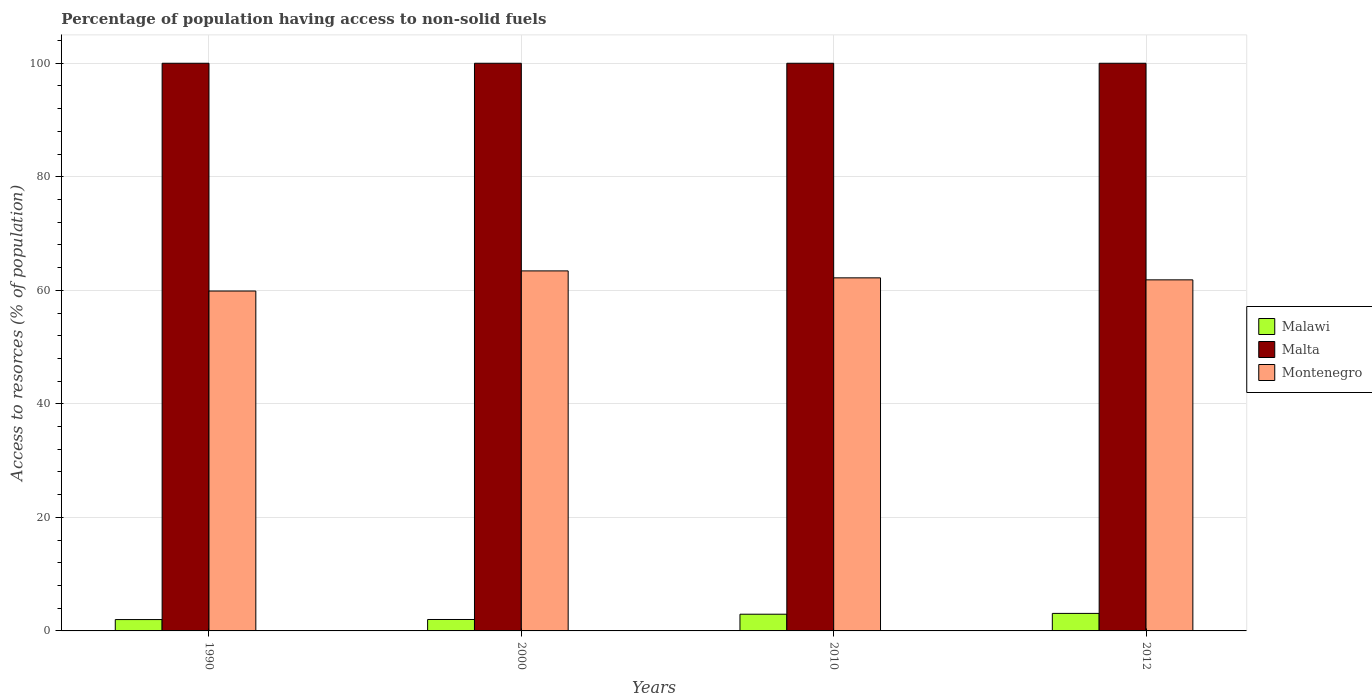Are the number of bars per tick equal to the number of legend labels?
Keep it short and to the point. Yes. Are the number of bars on each tick of the X-axis equal?
Provide a short and direct response. Yes. How many bars are there on the 2nd tick from the right?
Your response must be concise. 3. What is the percentage of population having access to non-solid fuels in Malawi in 2010?
Your answer should be compact. 2.94. Across all years, what is the maximum percentage of population having access to non-solid fuels in Montenegro?
Make the answer very short. 63.42. Across all years, what is the minimum percentage of population having access to non-solid fuels in Malawi?
Provide a short and direct response. 2. In which year was the percentage of population having access to non-solid fuels in Malta maximum?
Provide a succinct answer. 1990. In which year was the percentage of population having access to non-solid fuels in Malta minimum?
Your answer should be very brief. 1990. What is the total percentage of population having access to non-solid fuels in Malta in the graph?
Your answer should be very brief. 400. What is the difference between the percentage of population having access to non-solid fuels in Montenegro in 2000 and the percentage of population having access to non-solid fuels in Malta in 1990?
Offer a very short reply. -36.58. In the year 2012, what is the difference between the percentage of population having access to non-solid fuels in Montenegro and percentage of population having access to non-solid fuels in Malawi?
Give a very brief answer. 58.76. What is the ratio of the percentage of population having access to non-solid fuels in Malta in 1990 to that in 2000?
Make the answer very short. 1. What is the difference between the highest and the second highest percentage of population having access to non-solid fuels in Malawi?
Make the answer very short. 0.14. What is the difference between the highest and the lowest percentage of population having access to non-solid fuels in Montenegro?
Give a very brief answer. 3.54. Is the sum of the percentage of population having access to non-solid fuels in Malawi in 2010 and 2012 greater than the maximum percentage of population having access to non-solid fuels in Malta across all years?
Your answer should be very brief. No. What does the 1st bar from the left in 2000 represents?
Keep it short and to the point. Malawi. What does the 2nd bar from the right in 2012 represents?
Ensure brevity in your answer.  Malta. How many years are there in the graph?
Offer a terse response. 4. Are the values on the major ticks of Y-axis written in scientific E-notation?
Ensure brevity in your answer.  No. Does the graph contain any zero values?
Offer a very short reply. No. Where does the legend appear in the graph?
Give a very brief answer. Center right. What is the title of the graph?
Your answer should be compact. Percentage of population having access to non-solid fuels. What is the label or title of the Y-axis?
Your answer should be compact. Access to resorces (% of population). What is the Access to resorces (% of population) of Malawi in 1990?
Your answer should be compact. 2. What is the Access to resorces (% of population) in Malta in 1990?
Your answer should be very brief. 100. What is the Access to resorces (% of population) in Montenegro in 1990?
Give a very brief answer. 59.88. What is the Access to resorces (% of population) in Malawi in 2000?
Give a very brief answer. 2.01. What is the Access to resorces (% of population) in Malta in 2000?
Keep it short and to the point. 100. What is the Access to resorces (% of population) in Montenegro in 2000?
Your answer should be compact. 63.42. What is the Access to resorces (% of population) of Malawi in 2010?
Keep it short and to the point. 2.94. What is the Access to resorces (% of population) in Montenegro in 2010?
Provide a short and direct response. 62.2. What is the Access to resorces (% of population) of Malawi in 2012?
Make the answer very short. 3.09. What is the Access to resorces (% of population) of Malta in 2012?
Ensure brevity in your answer.  100. What is the Access to resorces (% of population) in Montenegro in 2012?
Offer a very short reply. 61.85. Across all years, what is the maximum Access to resorces (% of population) in Malawi?
Provide a succinct answer. 3.09. Across all years, what is the maximum Access to resorces (% of population) in Malta?
Your response must be concise. 100. Across all years, what is the maximum Access to resorces (% of population) in Montenegro?
Provide a short and direct response. 63.42. Across all years, what is the minimum Access to resorces (% of population) of Malawi?
Offer a terse response. 2. Across all years, what is the minimum Access to resorces (% of population) of Montenegro?
Make the answer very short. 59.88. What is the total Access to resorces (% of population) in Malawi in the graph?
Provide a short and direct response. 10.04. What is the total Access to resorces (% of population) of Malta in the graph?
Ensure brevity in your answer.  400. What is the total Access to resorces (% of population) of Montenegro in the graph?
Your response must be concise. 247.34. What is the difference between the Access to resorces (% of population) of Malawi in 1990 and that in 2000?
Your answer should be compact. -0.01. What is the difference between the Access to resorces (% of population) in Malta in 1990 and that in 2000?
Make the answer very short. 0. What is the difference between the Access to resorces (% of population) in Montenegro in 1990 and that in 2000?
Your response must be concise. -3.54. What is the difference between the Access to resorces (% of population) in Malawi in 1990 and that in 2010?
Offer a terse response. -0.94. What is the difference between the Access to resorces (% of population) of Montenegro in 1990 and that in 2010?
Your answer should be very brief. -2.32. What is the difference between the Access to resorces (% of population) of Malawi in 1990 and that in 2012?
Your response must be concise. -1.09. What is the difference between the Access to resorces (% of population) of Montenegro in 1990 and that in 2012?
Your response must be concise. -1.97. What is the difference between the Access to resorces (% of population) in Malawi in 2000 and that in 2010?
Offer a very short reply. -0.93. What is the difference between the Access to resorces (% of population) in Malta in 2000 and that in 2010?
Offer a terse response. 0. What is the difference between the Access to resorces (% of population) of Montenegro in 2000 and that in 2010?
Your response must be concise. 1.22. What is the difference between the Access to resorces (% of population) of Malawi in 2000 and that in 2012?
Your response must be concise. -1.07. What is the difference between the Access to resorces (% of population) of Montenegro in 2000 and that in 2012?
Provide a short and direct response. 1.58. What is the difference between the Access to resorces (% of population) of Malawi in 2010 and that in 2012?
Ensure brevity in your answer.  -0.14. What is the difference between the Access to resorces (% of population) in Montenegro in 2010 and that in 2012?
Give a very brief answer. 0.35. What is the difference between the Access to resorces (% of population) of Malawi in 1990 and the Access to resorces (% of population) of Malta in 2000?
Give a very brief answer. -98. What is the difference between the Access to resorces (% of population) of Malawi in 1990 and the Access to resorces (% of population) of Montenegro in 2000?
Keep it short and to the point. -61.42. What is the difference between the Access to resorces (% of population) of Malta in 1990 and the Access to resorces (% of population) of Montenegro in 2000?
Offer a terse response. 36.58. What is the difference between the Access to resorces (% of population) in Malawi in 1990 and the Access to resorces (% of population) in Malta in 2010?
Offer a terse response. -98. What is the difference between the Access to resorces (% of population) in Malawi in 1990 and the Access to resorces (% of population) in Montenegro in 2010?
Give a very brief answer. -60.2. What is the difference between the Access to resorces (% of population) in Malta in 1990 and the Access to resorces (% of population) in Montenegro in 2010?
Make the answer very short. 37.8. What is the difference between the Access to resorces (% of population) of Malawi in 1990 and the Access to resorces (% of population) of Malta in 2012?
Offer a terse response. -98. What is the difference between the Access to resorces (% of population) in Malawi in 1990 and the Access to resorces (% of population) in Montenegro in 2012?
Your answer should be compact. -59.85. What is the difference between the Access to resorces (% of population) of Malta in 1990 and the Access to resorces (% of population) of Montenegro in 2012?
Ensure brevity in your answer.  38.15. What is the difference between the Access to resorces (% of population) of Malawi in 2000 and the Access to resorces (% of population) of Malta in 2010?
Keep it short and to the point. -97.99. What is the difference between the Access to resorces (% of population) in Malawi in 2000 and the Access to resorces (% of population) in Montenegro in 2010?
Make the answer very short. -60.18. What is the difference between the Access to resorces (% of population) of Malta in 2000 and the Access to resorces (% of population) of Montenegro in 2010?
Your answer should be compact. 37.8. What is the difference between the Access to resorces (% of population) of Malawi in 2000 and the Access to resorces (% of population) of Malta in 2012?
Provide a succinct answer. -97.99. What is the difference between the Access to resorces (% of population) of Malawi in 2000 and the Access to resorces (% of population) of Montenegro in 2012?
Keep it short and to the point. -59.83. What is the difference between the Access to resorces (% of population) of Malta in 2000 and the Access to resorces (% of population) of Montenegro in 2012?
Ensure brevity in your answer.  38.15. What is the difference between the Access to resorces (% of population) in Malawi in 2010 and the Access to resorces (% of population) in Malta in 2012?
Provide a succinct answer. -97.06. What is the difference between the Access to resorces (% of population) of Malawi in 2010 and the Access to resorces (% of population) of Montenegro in 2012?
Give a very brief answer. -58.9. What is the difference between the Access to resorces (% of population) in Malta in 2010 and the Access to resorces (% of population) in Montenegro in 2012?
Offer a terse response. 38.15. What is the average Access to resorces (% of population) of Malawi per year?
Provide a short and direct response. 2.51. What is the average Access to resorces (% of population) of Malta per year?
Offer a terse response. 100. What is the average Access to resorces (% of population) in Montenegro per year?
Make the answer very short. 61.84. In the year 1990, what is the difference between the Access to resorces (% of population) of Malawi and Access to resorces (% of population) of Malta?
Give a very brief answer. -98. In the year 1990, what is the difference between the Access to resorces (% of population) in Malawi and Access to resorces (% of population) in Montenegro?
Offer a terse response. -57.88. In the year 1990, what is the difference between the Access to resorces (% of population) in Malta and Access to resorces (% of population) in Montenegro?
Your response must be concise. 40.12. In the year 2000, what is the difference between the Access to resorces (% of population) of Malawi and Access to resorces (% of population) of Malta?
Give a very brief answer. -97.99. In the year 2000, what is the difference between the Access to resorces (% of population) in Malawi and Access to resorces (% of population) in Montenegro?
Offer a very short reply. -61.41. In the year 2000, what is the difference between the Access to resorces (% of population) in Malta and Access to resorces (% of population) in Montenegro?
Your answer should be very brief. 36.58. In the year 2010, what is the difference between the Access to resorces (% of population) of Malawi and Access to resorces (% of population) of Malta?
Provide a short and direct response. -97.06. In the year 2010, what is the difference between the Access to resorces (% of population) in Malawi and Access to resorces (% of population) in Montenegro?
Provide a succinct answer. -59.25. In the year 2010, what is the difference between the Access to resorces (% of population) of Malta and Access to resorces (% of population) of Montenegro?
Keep it short and to the point. 37.8. In the year 2012, what is the difference between the Access to resorces (% of population) in Malawi and Access to resorces (% of population) in Malta?
Give a very brief answer. -96.91. In the year 2012, what is the difference between the Access to resorces (% of population) of Malawi and Access to resorces (% of population) of Montenegro?
Provide a succinct answer. -58.76. In the year 2012, what is the difference between the Access to resorces (% of population) of Malta and Access to resorces (% of population) of Montenegro?
Provide a succinct answer. 38.15. What is the ratio of the Access to resorces (% of population) in Malta in 1990 to that in 2000?
Give a very brief answer. 1. What is the ratio of the Access to resorces (% of population) of Montenegro in 1990 to that in 2000?
Your response must be concise. 0.94. What is the ratio of the Access to resorces (% of population) in Malawi in 1990 to that in 2010?
Keep it short and to the point. 0.68. What is the ratio of the Access to resorces (% of population) in Montenegro in 1990 to that in 2010?
Make the answer very short. 0.96. What is the ratio of the Access to resorces (% of population) in Malawi in 1990 to that in 2012?
Offer a terse response. 0.65. What is the ratio of the Access to resorces (% of population) of Montenegro in 1990 to that in 2012?
Ensure brevity in your answer.  0.97. What is the ratio of the Access to resorces (% of population) in Malawi in 2000 to that in 2010?
Give a very brief answer. 0.68. What is the ratio of the Access to resorces (% of population) of Malta in 2000 to that in 2010?
Provide a short and direct response. 1. What is the ratio of the Access to resorces (% of population) in Montenegro in 2000 to that in 2010?
Offer a very short reply. 1.02. What is the ratio of the Access to resorces (% of population) in Malawi in 2000 to that in 2012?
Keep it short and to the point. 0.65. What is the ratio of the Access to resorces (% of population) of Montenegro in 2000 to that in 2012?
Your answer should be compact. 1.03. What is the ratio of the Access to resorces (% of population) in Malawi in 2010 to that in 2012?
Your answer should be very brief. 0.95. What is the ratio of the Access to resorces (% of population) in Malta in 2010 to that in 2012?
Give a very brief answer. 1. What is the ratio of the Access to resorces (% of population) in Montenegro in 2010 to that in 2012?
Give a very brief answer. 1.01. What is the difference between the highest and the second highest Access to resorces (% of population) of Malawi?
Provide a short and direct response. 0.14. What is the difference between the highest and the second highest Access to resorces (% of population) in Malta?
Provide a succinct answer. 0. What is the difference between the highest and the second highest Access to resorces (% of population) in Montenegro?
Your answer should be compact. 1.22. What is the difference between the highest and the lowest Access to resorces (% of population) in Malawi?
Make the answer very short. 1.09. What is the difference between the highest and the lowest Access to resorces (% of population) in Malta?
Provide a succinct answer. 0. What is the difference between the highest and the lowest Access to resorces (% of population) of Montenegro?
Ensure brevity in your answer.  3.54. 